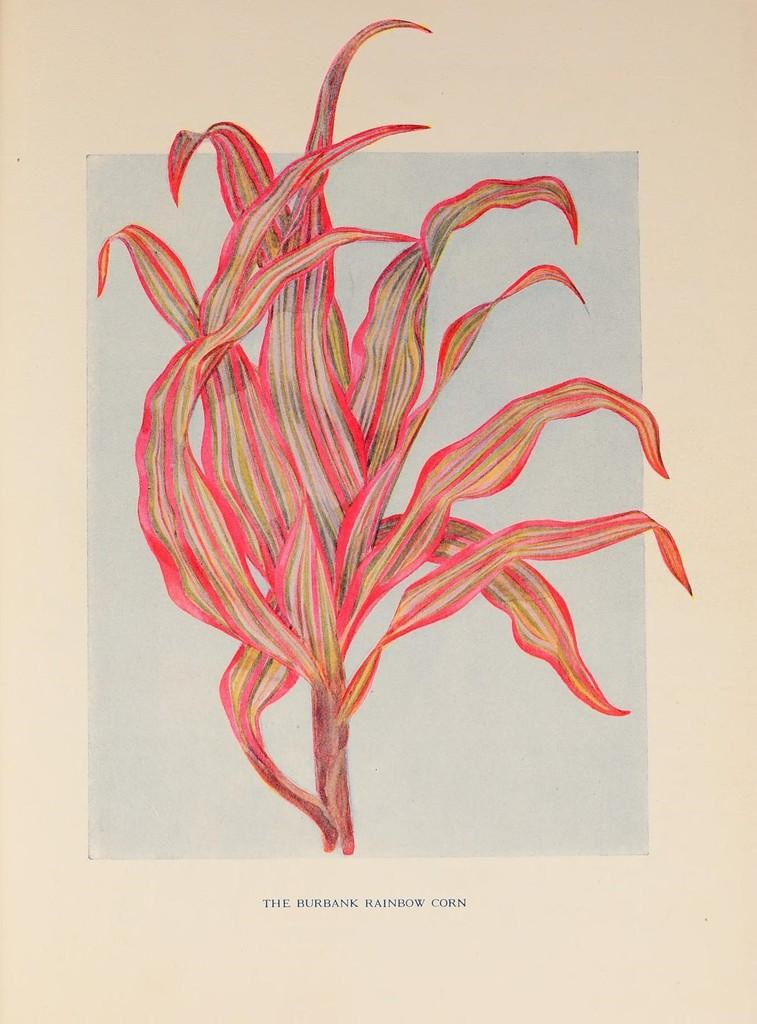What color is the plant that is drawn on the paper in the image? The plant that is drawn on the paper is pink. What is written on the paper in the image? The phrase "The rainbow crown" is written on the front bottom side of the paper. What type of muscle is being exercised by the plant in the image? There is no muscle or exercise depicted in the image; it features a drawing of a pink plant and a written phrase. 